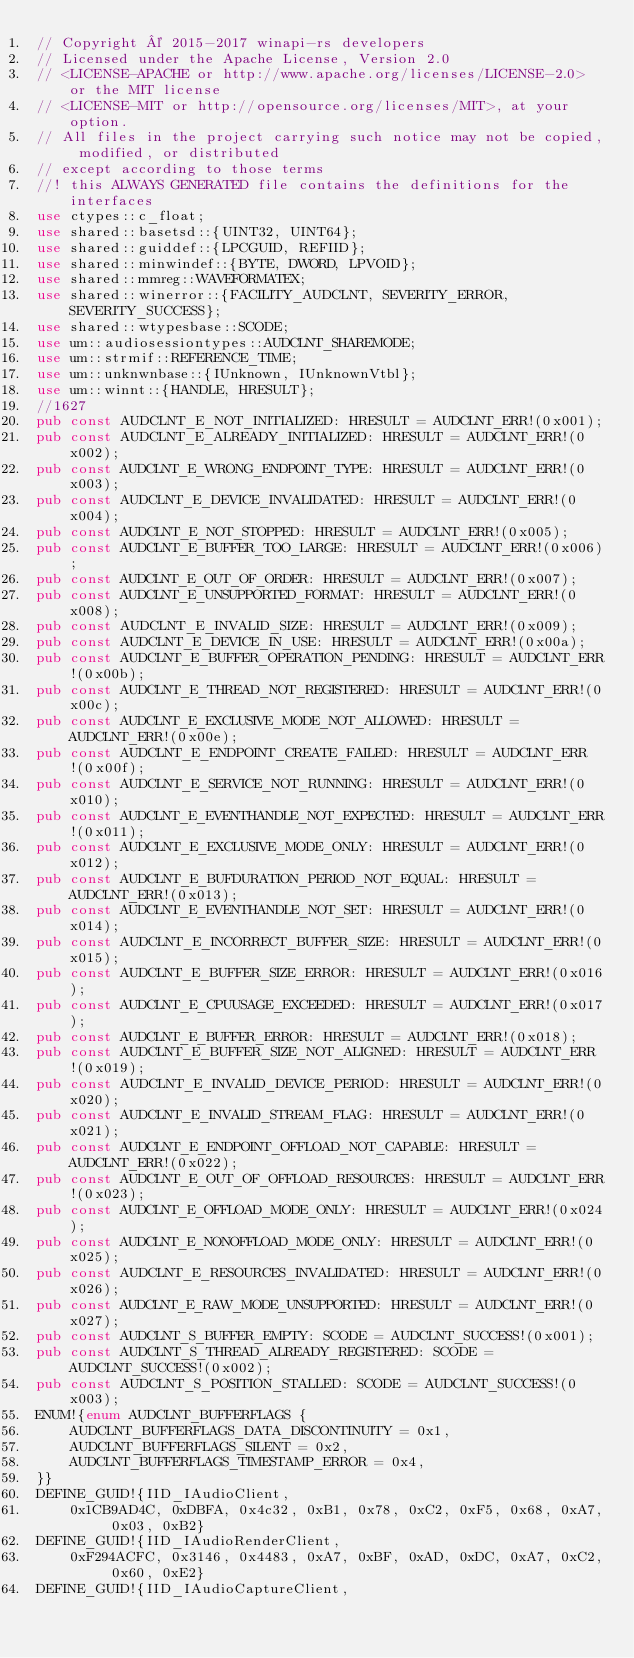<code> <loc_0><loc_0><loc_500><loc_500><_Rust_>// Copyright © 2015-2017 winapi-rs developers
// Licensed under the Apache License, Version 2.0
// <LICENSE-APACHE or http://www.apache.org/licenses/LICENSE-2.0> or the MIT license
// <LICENSE-MIT or http://opensource.org/licenses/MIT>, at your option.
// All files in the project carrying such notice may not be copied, modified, or distributed
// except according to those terms
//! this ALWAYS GENERATED file contains the definitions for the interfaces
use ctypes::c_float;
use shared::basetsd::{UINT32, UINT64};
use shared::guiddef::{LPCGUID, REFIID};
use shared::minwindef::{BYTE, DWORD, LPVOID};
use shared::mmreg::WAVEFORMATEX;
use shared::winerror::{FACILITY_AUDCLNT, SEVERITY_ERROR, SEVERITY_SUCCESS};
use shared::wtypesbase::SCODE;
use um::audiosessiontypes::AUDCLNT_SHAREMODE;
use um::strmif::REFERENCE_TIME;
use um::unknwnbase::{IUnknown, IUnknownVtbl};
use um::winnt::{HANDLE, HRESULT};
//1627
pub const AUDCLNT_E_NOT_INITIALIZED: HRESULT = AUDCLNT_ERR!(0x001);
pub const AUDCLNT_E_ALREADY_INITIALIZED: HRESULT = AUDCLNT_ERR!(0x002);
pub const AUDCLNT_E_WRONG_ENDPOINT_TYPE: HRESULT = AUDCLNT_ERR!(0x003);
pub const AUDCLNT_E_DEVICE_INVALIDATED: HRESULT = AUDCLNT_ERR!(0x004);
pub const AUDCLNT_E_NOT_STOPPED: HRESULT = AUDCLNT_ERR!(0x005);
pub const AUDCLNT_E_BUFFER_TOO_LARGE: HRESULT = AUDCLNT_ERR!(0x006);
pub const AUDCLNT_E_OUT_OF_ORDER: HRESULT = AUDCLNT_ERR!(0x007);
pub const AUDCLNT_E_UNSUPPORTED_FORMAT: HRESULT = AUDCLNT_ERR!(0x008);
pub const AUDCLNT_E_INVALID_SIZE: HRESULT = AUDCLNT_ERR!(0x009);
pub const AUDCLNT_E_DEVICE_IN_USE: HRESULT = AUDCLNT_ERR!(0x00a);
pub const AUDCLNT_E_BUFFER_OPERATION_PENDING: HRESULT = AUDCLNT_ERR!(0x00b);
pub const AUDCLNT_E_THREAD_NOT_REGISTERED: HRESULT = AUDCLNT_ERR!(0x00c);
pub const AUDCLNT_E_EXCLUSIVE_MODE_NOT_ALLOWED: HRESULT = AUDCLNT_ERR!(0x00e);
pub const AUDCLNT_E_ENDPOINT_CREATE_FAILED: HRESULT = AUDCLNT_ERR!(0x00f);
pub const AUDCLNT_E_SERVICE_NOT_RUNNING: HRESULT = AUDCLNT_ERR!(0x010);
pub const AUDCLNT_E_EVENTHANDLE_NOT_EXPECTED: HRESULT = AUDCLNT_ERR!(0x011);
pub const AUDCLNT_E_EXCLUSIVE_MODE_ONLY: HRESULT = AUDCLNT_ERR!(0x012);
pub const AUDCLNT_E_BUFDURATION_PERIOD_NOT_EQUAL: HRESULT = AUDCLNT_ERR!(0x013);
pub const AUDCLNT_E_EVENTHANDLE_NOT_SET: HRESULT = AUDCLNT_ERR!(0x014);
pub const AUDCLNT_E_INCORRECT_BUFFER_SIZE: HRESULT = AUDCLNT_ERR!(0x015);
pub const AUDCLNT_E_BUFFER_SIZE_ERROR: HRESULT = AUDCLNT_ERR!(0x016);
pub const AUDCLNT_E_CPUUSAGE_EXCEEDED: HRESULT = AUDCLNT_ERR!(0x017);
pub const AUDCLNT_E_BUFFER_ERROR: HRESULT = AUDCLNT_ERR!(0x018);
pub const AUDCLNT_E_BUFFER_SIZE_NOT_ALIGNED: HRESULT = AUDCLNT_ERR!(0x019);
pub const AUDCLNT_E_INVALID_DEVICE_PERIOD: HRESULT = AUDCLNT_ERR!(0x020);
pub const AUDCLNT_E_INVALID_STREAM_FLAG: HRESULT = AUDCLNT_ERR!(0x021);
pub const AUDCLNT_E_ENDPOINT_OFFLOAD_NOT_CAPABLE: HRESULT = AUDCLNT_ERR!(0x022);
pub const AUDCLNT_E_OUT_OF_OFFLOAD_RESOURCES: HRESULT = AUDCLNT_ERR!(0x023);
pub const AUDCLNT_E_OFFLOAD_MODE_ONLY: HRESULT = AUDCLNT_ERR!(0x024);
pub const AUDCLNT_E_NONOFFLOAD_MODE_ONLY: HRESULT = AUDCLNT_ERR!(0x025);
pub const AUDCLNT_E_RESOURCES_INVALIDATED: HRESULT = AUDCLNT_ERR!(0x026);
pub const AUDCLNT_E_RAW_MODE_UNSUPPORTED: HRESULT = AUDCLNT_ERR!(0x027);
pub const AUDCLNT_S_BUFFER_EMPTY: SCODE = AUDCLNT_SUCCESS!(0x001);
pub const AUDCLNT_S_THREAD_ALREADY_REGISTERED: SCODE = AUDCLNT_SUCCESS!(0x002);
pub const AUDCLNT_S_POSITION_STALLED: SCODE = AUDCLNT_SUCCESS!(0x003);
ENUM!{enum AUDCLNT_BUFFERFLAGS {
    AUDCLNT_BUFFERFLAGS_DATA_DISCONTINUITY = 0x1,
    AUDCLNT_BUFFERFLAGS_SILENT = 0x2,
    AUDCLNT_BUFFERFLAGS_TIMESTAMP_ERROR = 0x4,
}}
DEFINE_GUID!{IID_IAudioClient,
    0x1CB9AD4C, 0xDBFA, 0x4c32, 0xB1, 0x78, 0xC2, 0xF5, 0x68, 0xA7, 0x03, 0xB2}
DEFINE_GUID!{IID_IAudioRenderClient,
    0xF294ACFC, 0x3146, 0x4483, 0xA7, 0xBF, 0xAD, 0xDC, 0xA7, 0xC2, 0x60, 0xE2}
DEFINE_GUID!{IID_IAudioCaptureClient,</code> 